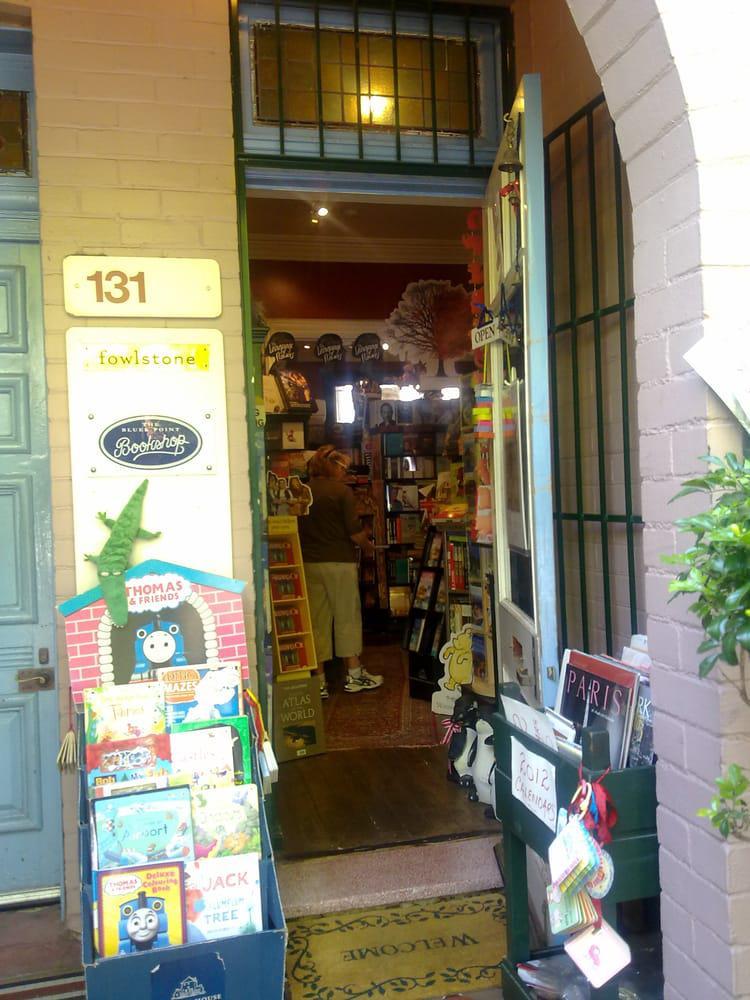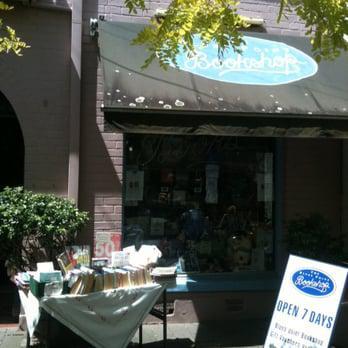The first image is the image on the left, the second image is the image on the right. Assess this claim about the two images: "In at least one image there is a single book display in the window with at least one neon sign hanging about the books.". Correct or not? Answer yes or no. No. The first image is the image on the left, the second image is the image on the right. Assess this claim about the two images: "The bookshop in the right image has an informational fold out sign out front.". Correct or not? Answer yes or no. Yes. 